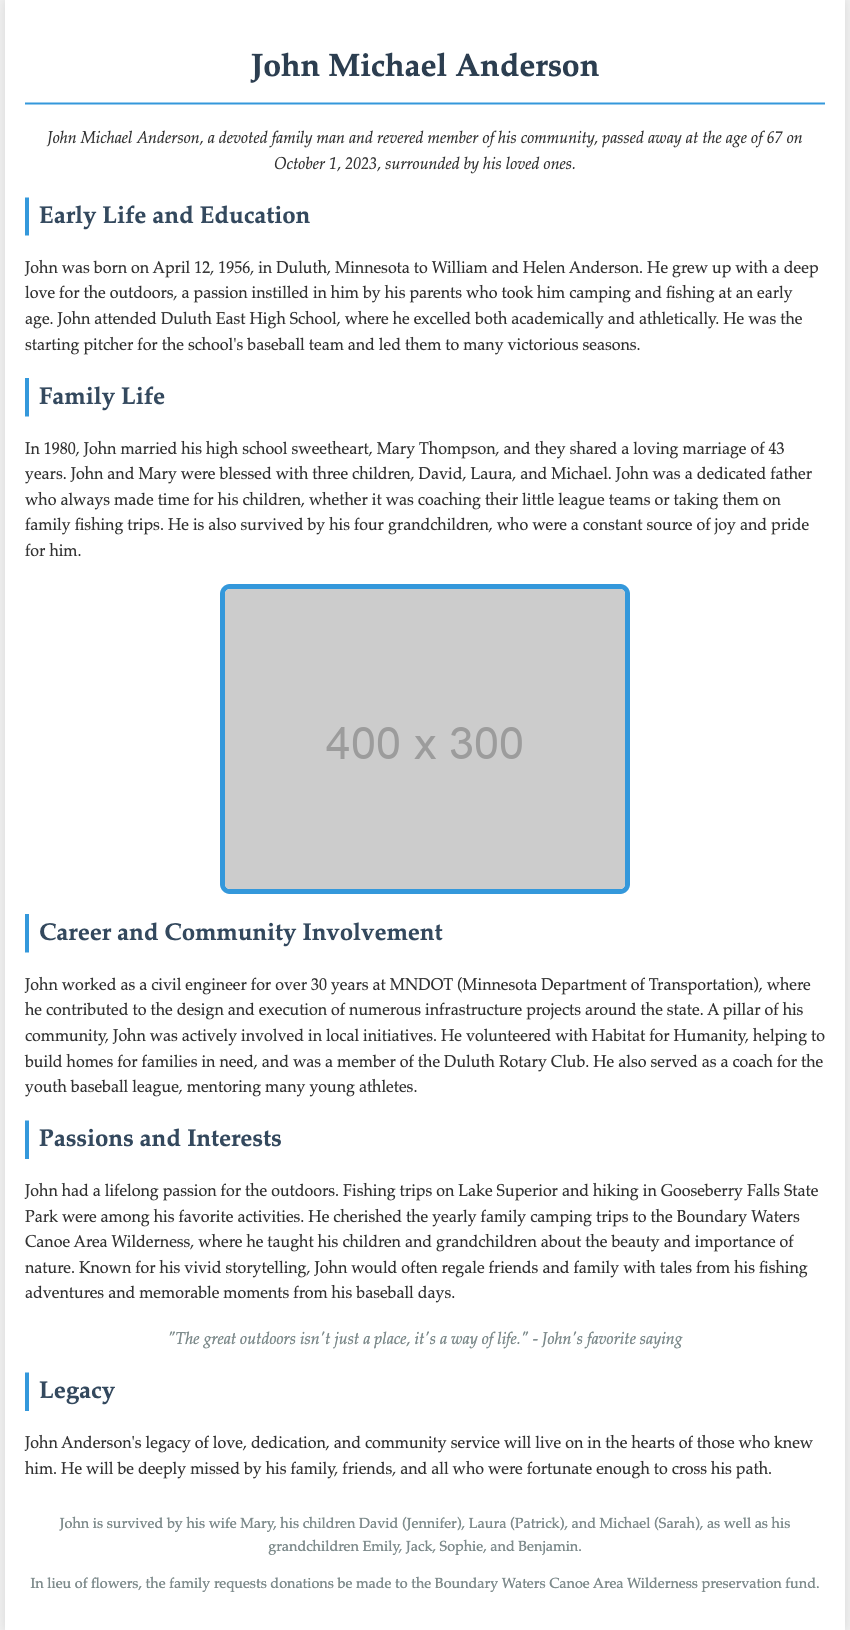What was John Michael Anderson's age at the time of his passing? John's age is explicitly stated as 67 years.
Answer: 67 What sport did John play in high school? The document mentions that he was the starting pitcher on the baseball team.
Answer: Baseball When did John marry Mary Thompson? The document provides the marriage year as 1980.
Answer: 1980 What is the name of the preservation fund requested for donations? The document specifies the Boundary Waters Canoe Area Wilderness preservation fund.
Answer: Boundary Waters Canoe Area Wilderness What was John's profession? The obituary states that John worked as a civil engineer for MNDOT.
Answer: Civil engineer How many children did John have? The document mentions that John was blessed with three children.
Answer: Three What community club was John a member of? The obituary notes his membership in the Duluth Rotary Club.
Answer: Duluth Rotary Club What outdoor activity did John enjoy with his family? The document indicates that he cherished yearly family camping trips.
Answer: Camping trips What was one of John's favorite sayings? The obituary quotes him saying, "The great outdoors isn't just a place, it's a way of life."
Answer: "The great outdoors isn't just a place, it's a way of life." 